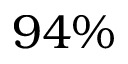<formula> <loc_0><loc_0><loc_500><loc_500>9 4 \%</formula> 